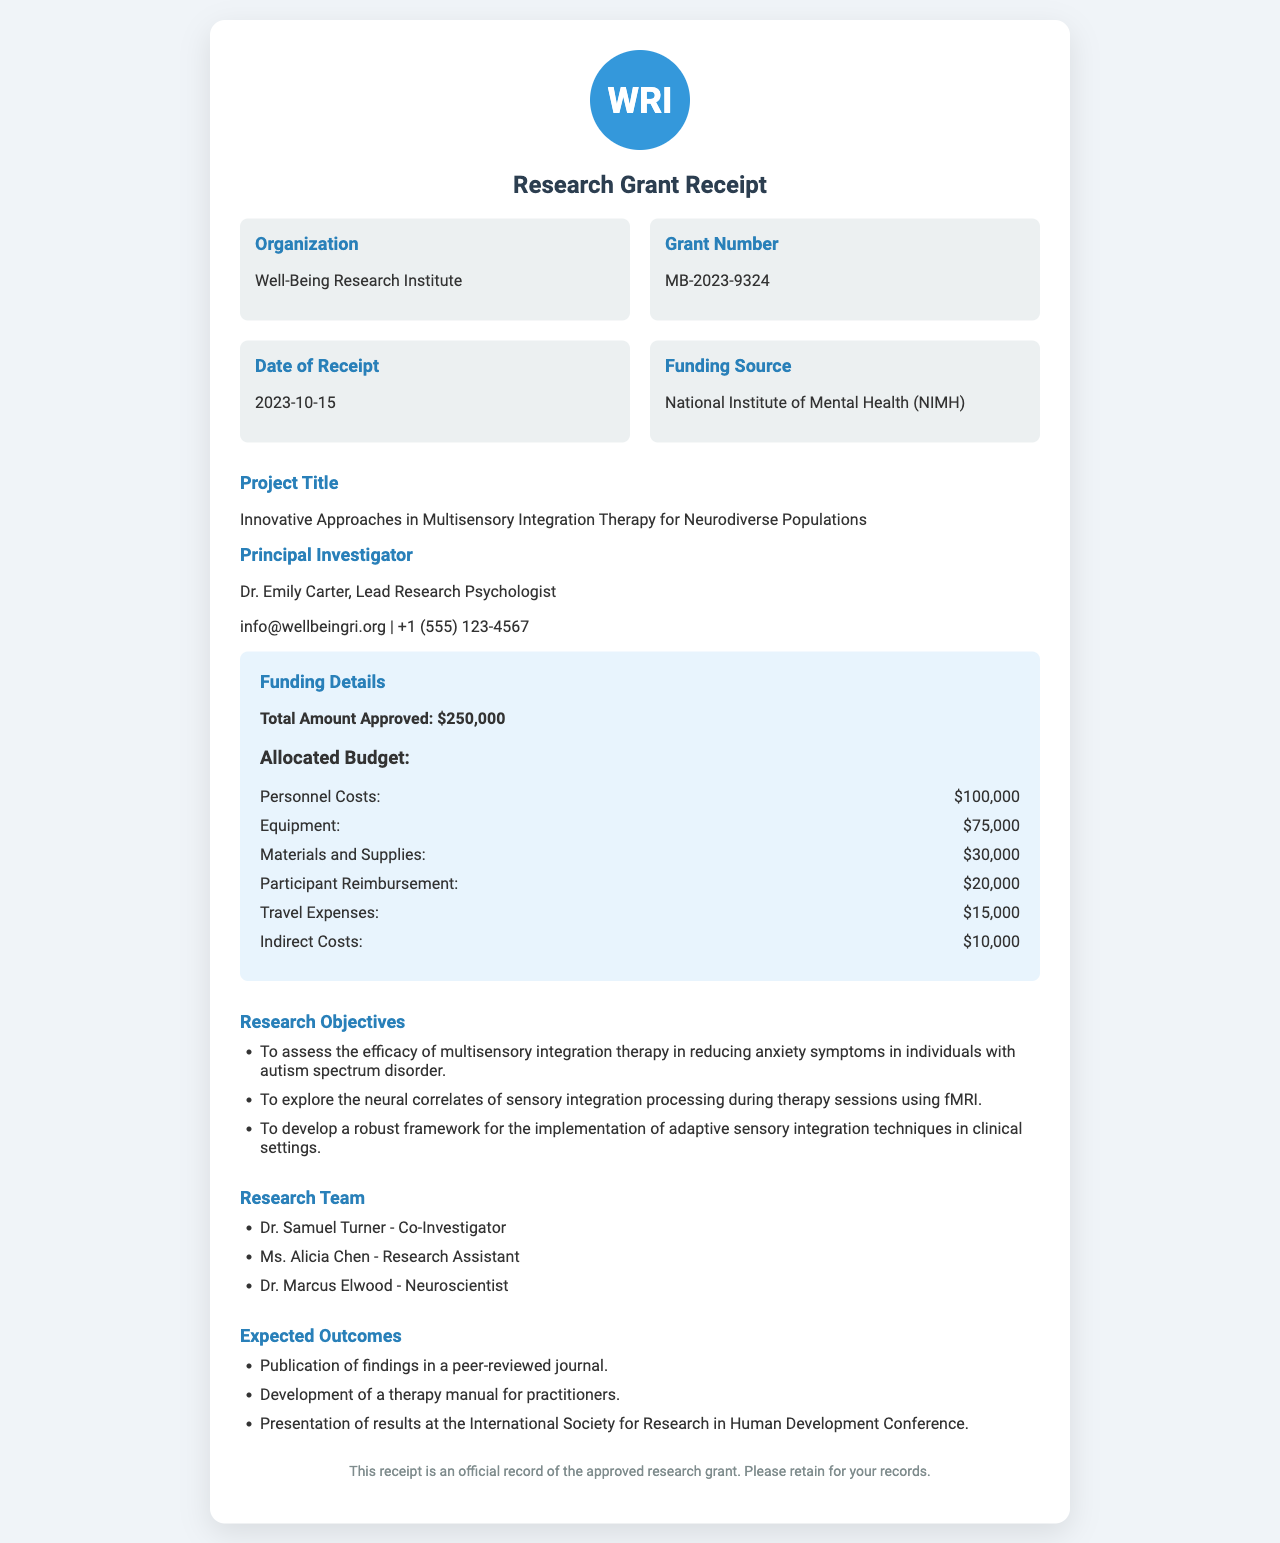What is the grant number? The grant number is specifically listed in the document as MB-2023-9324.
Answer: MB-2023-9324 What is the total amount approved for the project? The total amount approved is clearly stated in the funding details section of the document.
Answer: $250,000 Who is the principal investigator? The principal investigator's name and role are mentioned under the project title section.
Answer: Dr. Emily Carter, Lead Research Psychologist What is the funding source? The document lists the funding source under the details section.
Answer: National Institute of Mental Health (NIMH) What are the personnel costs allocated in the budget? The personnel costs are one of the budget items specified in the funding details.
Answer: $100,000 What is one of the expected outcomes of the research project? Expected outcomes are listed in the document, providing insights into the project's goals.
Answer: Publication of findings in a peer-reviewed journal How many research team members are listed? The number of team members is shown in the research team section of the document.
Answer: Three Which research objective involves the use of fMRI? One of the research objectives refers specifically to neural correlates and monitoring during therapy sessions.
Answer: To explore the neural correlates of sensory integration processing during therapy sessions using fMRI What is the project's title? The project title is clearly indicated in the document.
Answer: Innovative Approaches in Multisensory Integration Therapy for Neurodiverse Populations 